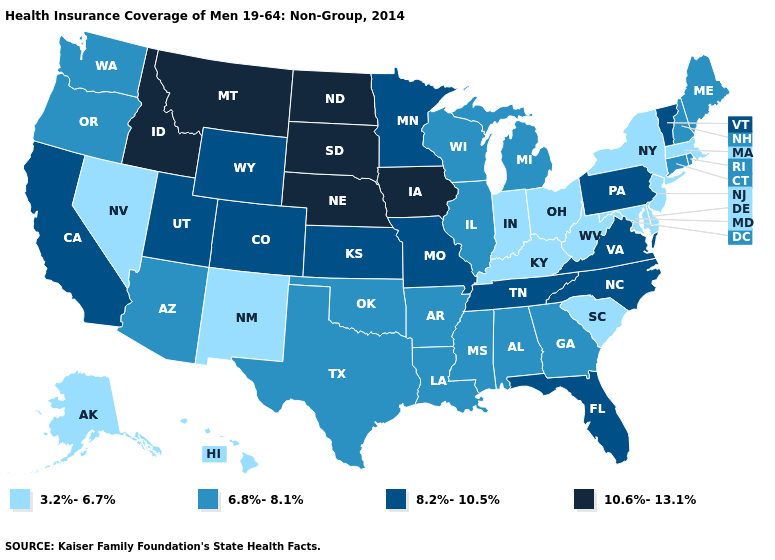Name the states that have a value in the range 6.8%-8.1%?
Short answer required. Alabama, Arizona, Arkansas, Connecticut, Georgia, Illinois, Louisiana, Maine, Michigan, Mississippi, New Hampshire, Oklahoma, Oregon, Rhode Island, Texas, Washington, Wisconsin. Does North Carolina have the highest value in the South?
Give a very brief answer. Yes. What is the lowest value in the USA?
Keep it brief. 3.2%-6.7%. Does the map have missing data?
Quick response, please. No. Which states have the lowest value in the West?
Quick response, please. Alaska, Hawaii, Nevada, New Mexico. Name the states that have a value in the range 3.2%-6.7%?
Answer briefly. Alaska, Delaware, Hawaii, Indiana, Kentucky, Maryland, Massachusetts, Nevada, New Jersey, New Mexico, New York, Ohio, South Carolina, West Virginia. Name the states that have a value in the range 6.8%-8.1%?
Answer briefly. Alabama, Arizona, Arkansas, Connecticut, Georgia, Illinois, Louisiana, Maine, Michigan, Mississippi, New Hampshire, Oklahoma, Oregon, Rhode Island, Texas, Washington, Wisconsin. Is the legend a continuous bar?
Answer briefly. No. Among the states that border Maryland , does Delaware have the lowest value?
Keep it brief. Yes. What is the lowest value in the West?
Quick response, please. 3.2%-6.7%. Does Alabama have the highest value in the USA?
Answer briefly. No. Name the states that have a value in the range 3.2%-6.7%?
Write a very short answer. Alaska, Delaware, Hawaii, Indiana, Kentucky, Maryland, Massachusetts, Nevada, New Jersey, New Mexico, New York, Ohio, South Carolina, West Virginia. Name the states that have a value in the range 10.6%-13.1%?
Give a very brief answer. Idaho, Iowa, Montana, Nebraska, North Dakota, South Dakota. Does Tennessee have a higher value than Oklahoma?
Keep it brief. Yes. Does the first symbol in the legend represent the smallest category?
Answer briefly. Yes. 